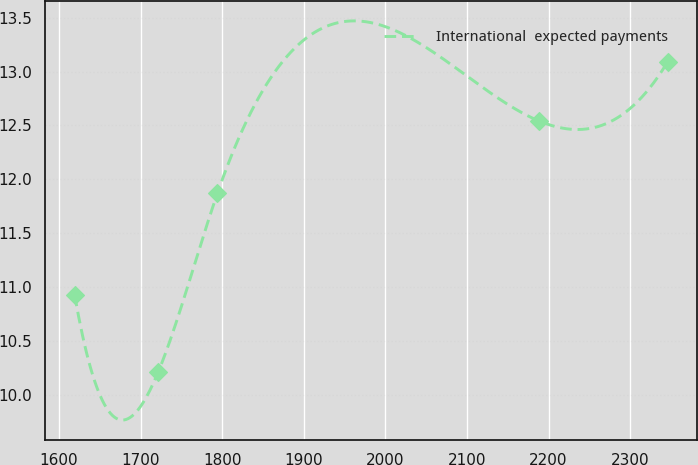Convert chart. <chart><loc_0><loc_0><loc_500><loc_500><line_chart><ecel><fcel>International  expected payments<nl><fcel>1619.16<fcel>10.93<nl><fcel>1721.49<fcel>10.21<nl><fcel>1794.16<fcel>11.87<nl><fcel>2188.72<fcel>12.54<nl><fcel>2345.86<fcel>13.09<nl></chart> 